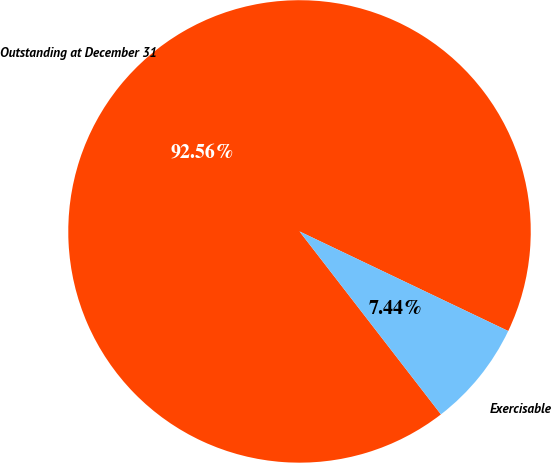Convert chart to OTSL. <chart><loc_0><loc_0><loc_500><loc_500><pie_chart><fcel>Outstanding at December 31<fcel>Exercisable<nl><fcel>92.56%<fcel>7.44%<nl></chart> 